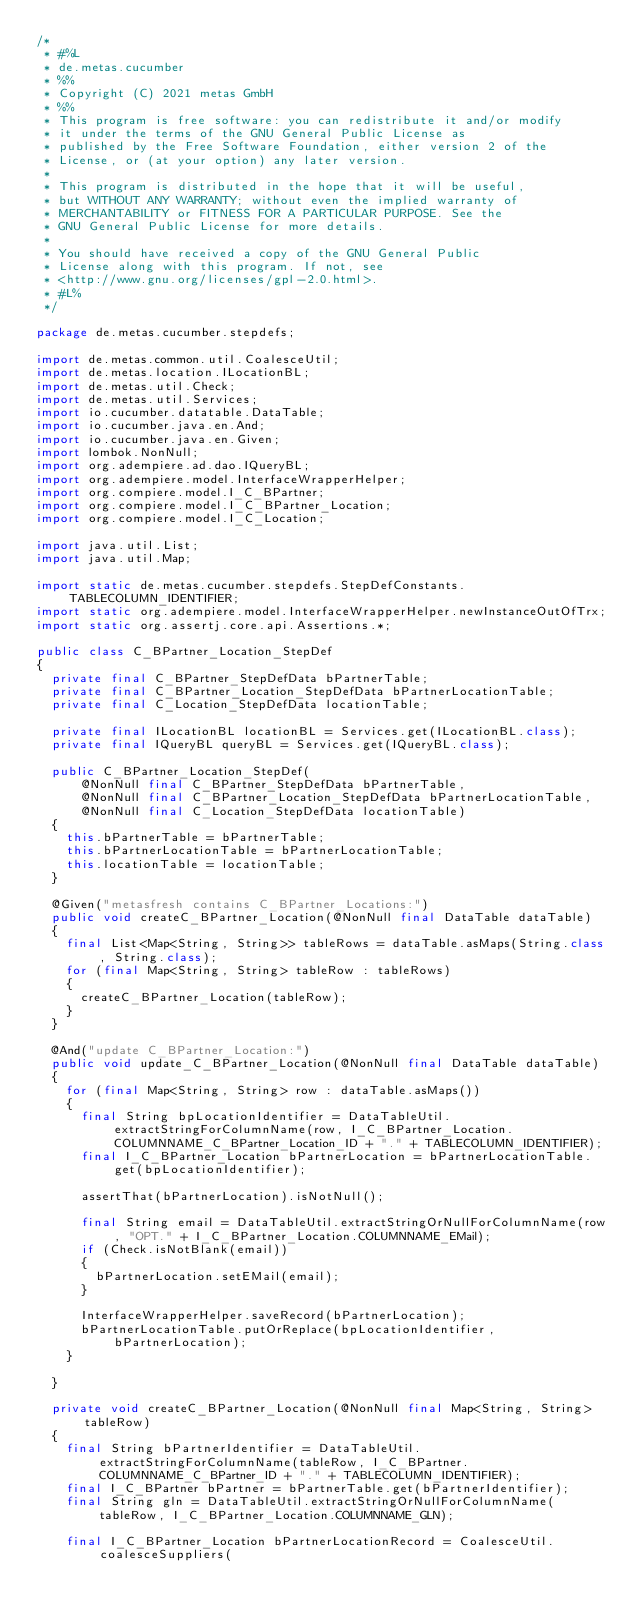Convert code to text. <code><loc_0><loc_0><loc_500><loc_500><_Java_>/*
 * #%L
 * de.metas.cucumber
 * %%
 * Copyright (C) 2021 metas GmbH
 * %%
 * This program is free software: you can redistribute it and/or modify
 * it under the terms of the GNU General Public License as
 * published by the Free Software Foundation, either version 2 of the
 * License, or (at your option) any later version.
 *
 * This program is distributed in the hope that it will be useful,
 * but WITHOUT ANY WARRANTY; without even the implied warranty of
 * MERCHANTABILITY or FITNESS FOR A PARTICULAR PURPOSE. See the
 * GNU General Public License for more details.
 *
 * You should have received a copy of the GNU General Public
 * License along with this program. If not, see
 * <http://www.gnu.org/licenses/gpl-2.0.html>.
 * #L%
 */

package de.metas.cucumber.stepdefs;

import de.metas.common.util.CoalesceUtil;
import de.metas.location.ILocationBL;
import de.metas.util.Check;
import de.metas.util.Services;
import io.cucumber.datatable.DataTable;
import io.cucumber.java.en.And;
import io.cucumber.java.en.Given;
import lombok.NonNull;
import org.adempiere.ad.dao.IQueryBL;
import org.adempiere.model.InterfaceWrapperHelper;
import org.compiere.model.I_C_BPartner;
import org.compiere.model.I_C_BPartner_Location;
import org.compiere.model.I_C_Location;

import java.util.List;
import java.util.Map;

import static de.metas.cucumber.stepdefs.StepDefConstants.TABLECOLUMN_IDENTIFIER;
import static org.adempiere.model.InterfaceWrapperHelper.newInstanceOutOfTrx;
import static org.assertj.core.api.Assertions.*;

public class C_BPartner_Location_StepDef
{
	private final C_BPartner_StepDefData bPartnerTable;
	private final C_BPartner_Location_StepDefData bPartnerLocationTable;
	private final C_Location_StepDefData locationTable;

	private final ILocationBL locationBL = Services.get(ILocationBL.class);
	private final IQueryBL queryBL = Services.get(IQueryBL.class);

	public C_BPartner_Location_StepDef(
			@NonNull final C_BPartner_StepDefData bPartnerTable,
			@NonNull final C_BPartner_Location_StepDefData bPartnerLocationTable,
			@NonNull final C_Location_StepDefData locationTable)
	{
		this.bPartnerTable = bPartnerTable;
		this.bPartnerLocationTable = bPartnerLocationTable;
		this.locationTable = locationTable;
	}

	@Given("metasfresh contains C_BPartner_Locations:")
	public void createC_BPartner_Location(@NonNull final DataTable dataTable)
	{
		final List<Map<String, String>> tableRows = dataTable.asMaps(String.class, String.class);
		for (final Map<String, String> tableRow : tableRows)
		{
			createC_BPartner_Location(tableRow);
		}
	}

	@And("update C_BPartner_Location:")
	public void update_C_BPartner_Location(@NonNull final DataTable dataTable)
	{
		for (final Map<String, String> row : dataTable.asMaps())
		{
			final String bpLocationIdentifier = DataTableUtil.extractStringForColumnName(row, I_C_BPartner_Location.COLUMNNAME_C_BPartner_Location_ID + "." + TABLECOLUMN_IDENTIFIER);
			final I_C_BPartner_Location bPartnerLocation = bPartnerLocationTable.get(bpLocationIdentifier);

			assertThat(bPartnerLocation).isNotNull();

			final String email = DataTableUtil.extractStringOrNullForColumnName(row, "OPT." + I_C_BPartner_Location.COLUMNNAME_EMail);
			if (Check.isNotBlank(email))
			{
				bPartnerLocation.setEMail(email);
			}

			InterfaceWrapperHelper.saveRecord(bPartnerLocation);
			bPartnerLocationTable.putOrReplace(bpLocationIdentifier, bPartnerLocation);
		}

	}

	private void createC_BPartner_Location(@NonNull final Map<String, String> tableRow)
	{
		final String bPartnerIdentifier = DataTableUtil.extractStringForColumnName(tableRow, I_C_BPartner.COLUMNNAME_C_BPartner_ID + "." + TABLECOLUMN_IDENTIFIER);
		final I_C_BPartner bPartner = bPartnerTable.get(bPartnerIdentifier);
		final String gln = DataTableUtil.extractStringOrNullForColumnName(tableRow, I_C_BPartner_Location.COLUMNNAME_GLN);

		final I_C_BPartner_Location bPartnerLocationRecord = CoalesceUtil.coalesceSuppliers(</code> 